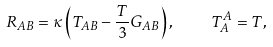Convert formula to latex. <formula><loc_0><loc_0><loc_500><loc_500>R _ { A B } = \kappa \left ( T _ { A B } - \frac { T } { 3 } G _ { A B } \right ) , \quad T _ { A } ^ { A } = T ,</formula> 